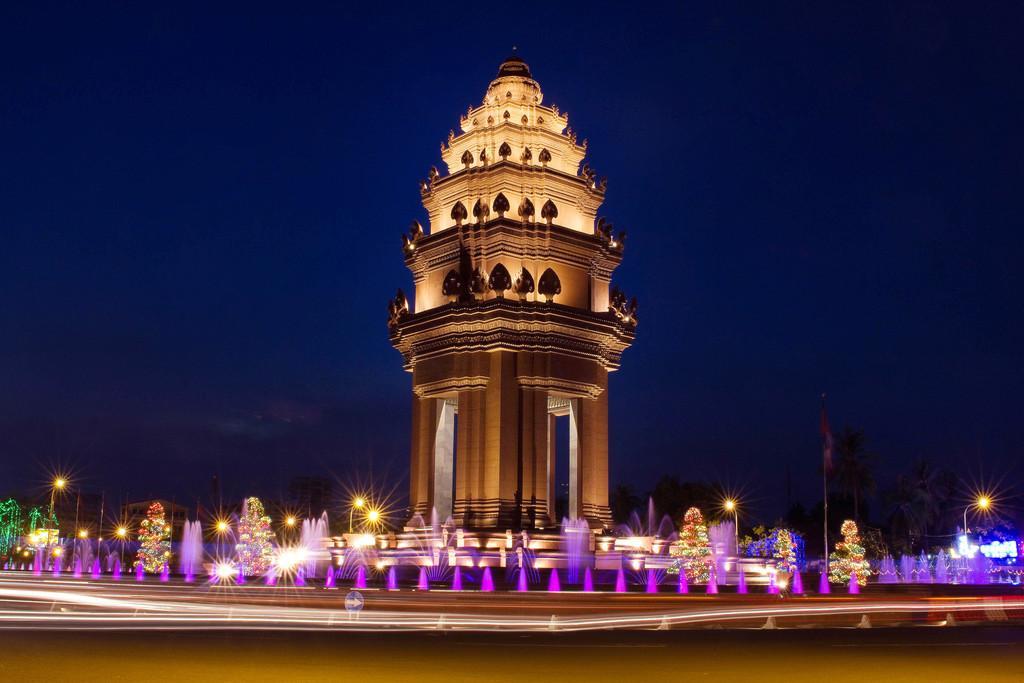Could you give a brief overview of what you see in this image? In the image we can see there is a building and in front there are fountains. Behind there are trees. 